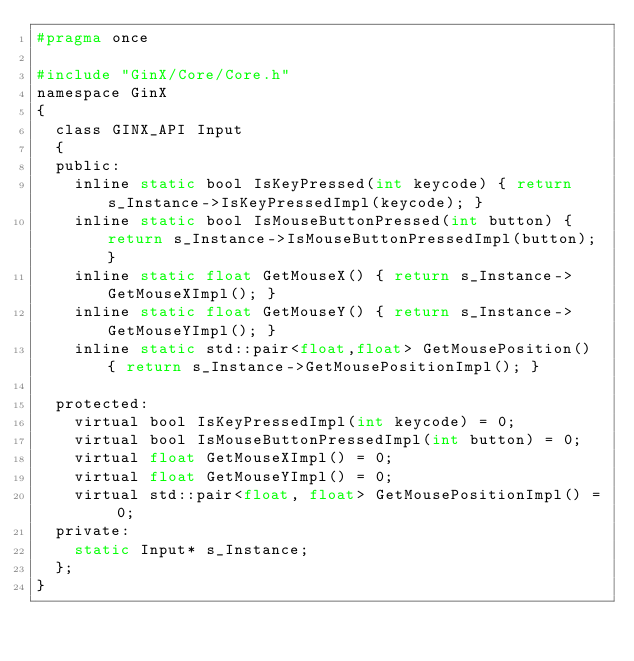<code> <loc_0><loc_0><loc_500><loc_500><_C_>#pragma once

#include "GinX/Core/Core.h"
namespace GinX
{
	class GINX_API Input
	{
	public:
		inline static bool IsKeyPressed(int keycode) { return s_Instance->IsKeyPressedImpl(keycode); }
		inline static bool IsMouseButtonPressed(int button) { return s_Instance->IsMouseButtonPressedImpl(button); }
		inline static float GetMouseX() { return s_Instance->GetMouseXImpl(); }
		inline static float GetMouseY() { return s_Instance->GetMouseYImpl(); }
		inline static std::pair<float,float> GetMousePosition() { return s_Instance->GetMousePositionImpl(); }

	protected:
		virtual bool IsKeyPressedImpl(int keycode) = 0;
		virtual bool IsMouseButtonPressedImpl(int button) = 0;
		virtual float GetMouseXImpl() = 0;
		virtual float GetMouseYImpl() = 0;
		virtual std::pair<float, float> GetMousePositionImpl() = 0;
	private:
		static Input* s_Instance;
	};
}</code> 